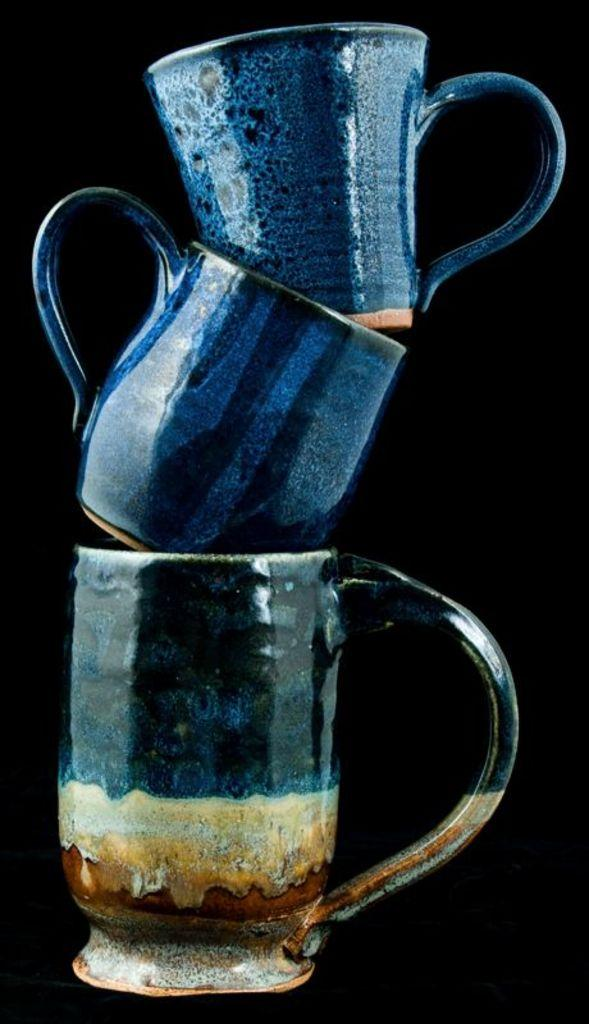What is the main object in the image? There is a cup in the image. Are there any other cups visible in the image? Yes, there is a cup on top of the first cup, and a third cup on top of the second cup. What is the color of the background in the image? The background of the image is black. What type of cat can be seen sitting on the egg in the image? There is no cat or egg present in the image; it only features three cups stacked on top of each other against a black background. 